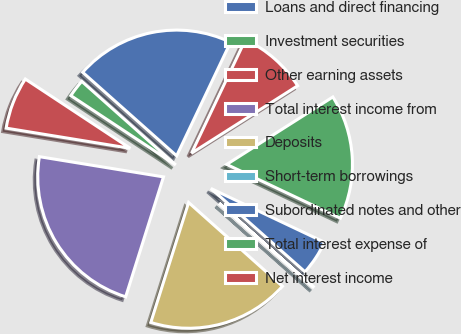Convert chart. <chart><loc_0><loc_0><loc_500><loc_500><pie_chart><fcel>Loans and direct financing<fcel>Investment securities<fcel>Other earning assets<fcel>Total interest income from<fcel>Deposits<fcel>Short-term borrowings<fcel>Subordinated notes and other<fcel>Total interest expense of<fcel>Net interest income<nl><fcel>20.49%<fcel>2.28%<fcel>6.72%<fcel>22.71%<fcel>18.27%<fcel>0.06%<fcel>4.5%<fcel>16.05%<fcel>8.94%<nl></chart> 